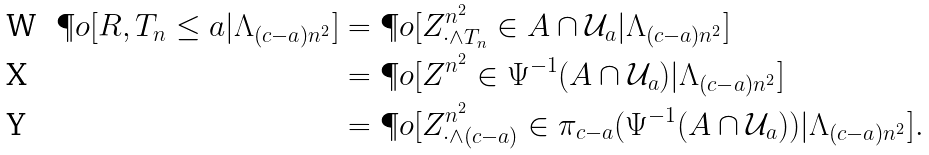Convert formula to latex. <formula><loc_0><loc_0><loc_500><loc_500>\P o [ R , T _ { n } \leq a | \Lambda _ { ( c - a ) n ^ { 2 } } ] & = \P o [ Z ^ { n ^ { 2 } } _ { \cdot \wedge T _ { n } } \in A \cap \mathcal { U } _ { a } | \Lambda _ { ( c - a ) n ^ { 2 } } ] \\ & = \P o [ Z ^ { n ^ { 2 } } \in \Psi ^ { - 1 } ( A \cap \mathcal { U } _ { a } ) | \Lambda _ { ( c - a ) n ^ { 2 } } ] \\ & = \P o [ Z ^ { n ^ { 2 } } _ { \cdot \wedge ( c - a ) } \in \pi _ { c - a } ( \Psi ^ { - 1 } ( A \cap \mathcal { U } _ { a } ) ) | \Lambda _ { ( c - a ) n ^ { 2 } } ] .</formula> 